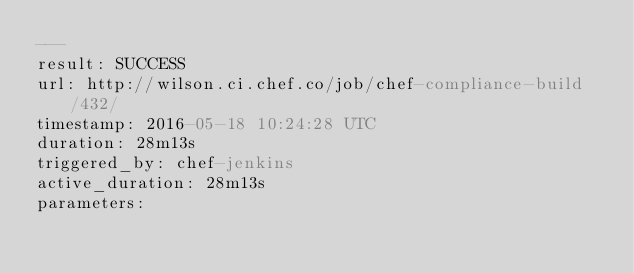Convert code to text. <code><loc_0><loc_0><loc_500><loc_500><_YAML_>---
result: SUCCESS
url: http://wilson.ci.chef.co/job/chef-compliance-build/432/
timestamp: 2016-05-18 10:24:28 UTC
duration: 28m13s
triggered_by: chef-jenkins
active_duration: 28m13s
parameters:</code> 